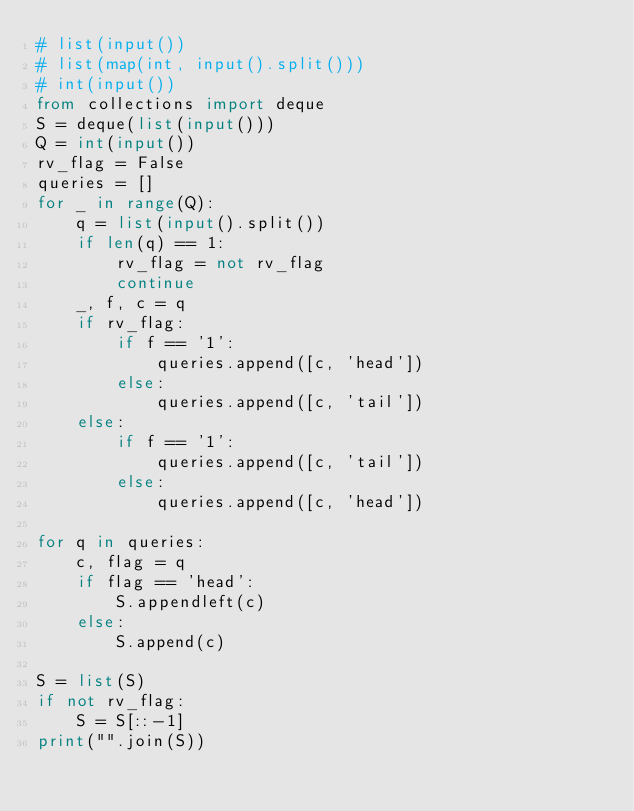Convert code to text. <code><loc_0><loc_0><loc_500><loc_500><_Python_># list(input())
# list(map(int, input().split()))
# int(input())
from collections import deque
S = deque(list(input()))
Q = int(input())
rv_flag = False
queries = []
for _ in range(Q):
    q = list(input().split())
    if len(q) == 1:
        rv_flag = not rv_flag
        continue
    _, f, c = q
    if rv_flag:
        if f == '1':
            queries.append([c, 'head'])
        else:
            queries.append([c, 'tail'])
    else:
        if f == '1':
            queries.append([c, 'tail'])
        else:
            queries.append([c, 'head'])

for q in queries:
    c, flag = q
    if flag == 'head':
        S.appendleft(c)
    else:
        S.append(c)

S = list(S)
if not rv_flag:
    S = S[::-1]
print("".join(S))

        

</code> 